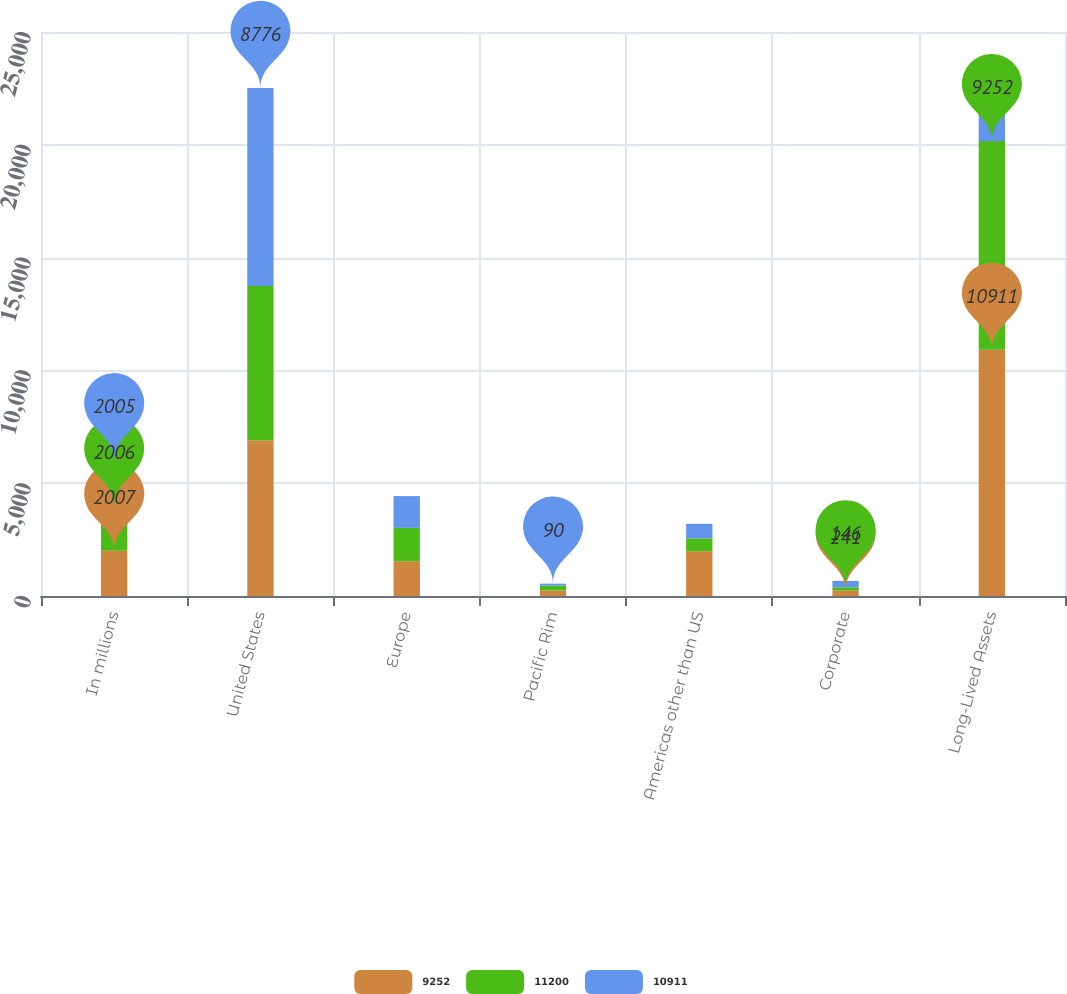Convert chart. <chart><loc_0><loc_0><loc_500><loc_500><stacked_bar_chart><ecel><fcel>In millions<fcel>United States<fcel>Europe<fcel>Pacific Rim<fcel>Americas other than US<fcel>Corporate<fcel>Long-Lived Assets<nl><fcel>9252<fcel>2007<fcel>6905<fcel>1540<fcel>244<fcel>1981<fcel>241<fcel>10911<nl><fcel>11200<fcel>2006<fcel>6837<fcel>1481<fcel>214<fcel>574<fcel>146<fcel>9252<nl><fcel>10911<fcel>2005<fcel>8776<fcel>1408<fcel>90<fcel>644<fcel>282<fcel>1510.5<nl></chart> 